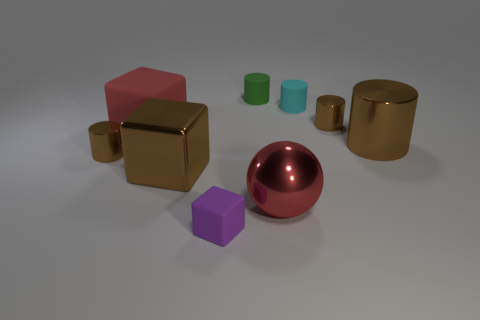Subtract all gray balls. How many brown cylinders are left? 3 Subtract all brown metal cylinders. How many cylinders are left? 2 Subtract all cyan cylinders. How many cylinders are left? 4 Subtract all yellow cubes. Subtract all green cylinders. How many cubes are left? 3 Subtract all spheres. How many objects are left? 8 Add 2 tiny yellow rubber cylinders. How many tiny yellow rubber cylinders exist? 2 Subtract 0 yellow balls. How many objects are left? 9 Subtract all green cylinders. Subtract all big cubes. How many objects are left? 6 Add 5 tiny purple things. How many tiny purple things are left? 6 